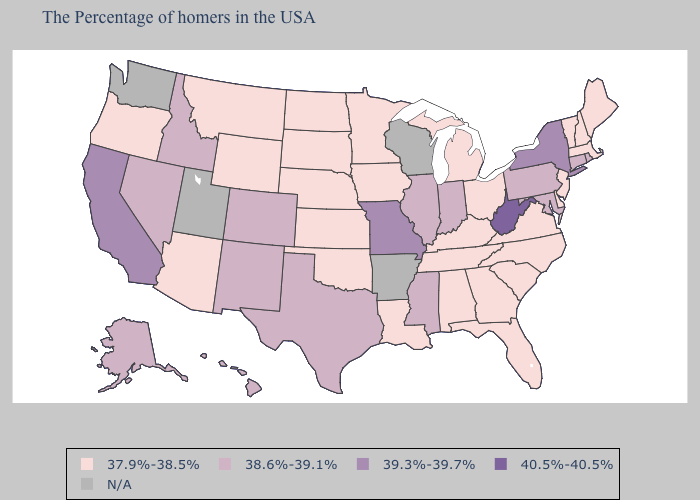Does Florida have the highest value in the USA?
Short answer required. No. What is the value of Florida?
Keep it brief. 37.9%-38.5%. Does New Hampshire have the highest value in the Northeast?
Short answer required. No. Name the states that have a value in the range 40.5%-40.5%?
Give a very brief answer. West Virginia. What is the value of Alaska?
Concise answer only. 38.6%-39.1%. Name the states that have a value in the range N/A?
Concise answer only. Wisconsin, Arkansas, Utah, Washington. Which states have the lowest value in the MidWest?
Quick response, please. Ohio, Michigan, Minnesota, Iowa, Kansas, Nebraska, South Dakota, North Dakota. What is the value of Washington?
Quick response, please. N/A. What is the value of Wyoming?
Answer briefly. 37.9%-38.5%. Name the states that have a value in the range N/A?
Write a very short answer. Wisconsin, Arkansas, Utah, Washington. Among the states that border Missouri , which have the highest value?
Concise answer only. Illinois. What is the value of California?
Be succinct. 39.3%-39.7%. What is the lowest value in the MidWest?
Be succinct. 37.9%-38.5%. Is the legend a continuous bar?
Be succinct. No. 